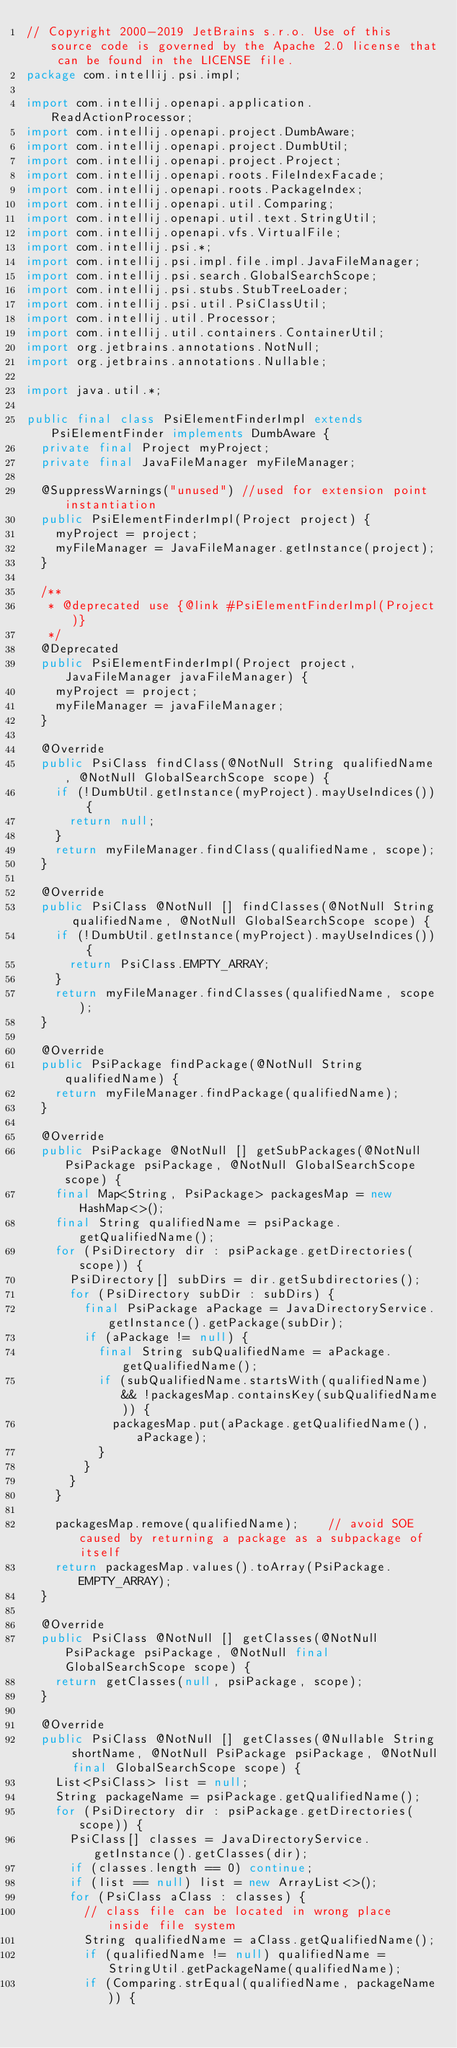<code> <loc_0><loc_0><loc_500><loc_500><_Java_>// Copyright 2000-2019 JetBrains s.r.o. Use of this source code is governed by the Apache 2.0 license that can be found in the LICENSE file.
package com.intellij.psi.impl;

import com.intellij.openapi.application.ReadActionProcessor;
import com.intellij.openapi.project.DumbAware;
import com.intellij.openapi.project.DumbUtil;
import com.intellij.openapi.project.Project;
import com.intellij.openapi.roots.FileIndexFacade;
import com.intellij.openapi.roots.PackageIndex;
import com.intellij.openapi.util.Comparing;
import com.intellij.openapi.util.text.StringUtil;
import com.intellij.openapi.vfs.VirtualFile;
import com.intellij.psi.*;
import com.intellij.psi.impl.file.impl.JavaFileManager;
import com.intellij.psi.search.GlobalSearchScope;
import com.intellij.psi.stubs.StubTreeLoader;
import com.intellij.psi.util.PsiClassUtil;
import com.intellij.util.Processor;
import com.intellij.util.containers.ContainerUtil;
import org.jetbrains.annotations.NotNull;
import org.jetbrains.annotations.Nullable;

import java.util.*;

public final class PsiElementFinderImpl extends PsiElementFinder implements DumbAware {
  private final Project myProject;
  private final JavaFileManager myFileManager;

  @SuppressWarnings("unused") //used for extension point instantiation
  public PsiElementFinderImpl(Project project) {
    myProject = project;
    myFileManager = JavaFileManager.getInstance(project);
  }

  /**
   * @deprecated use {@link #PsiElementFinderImpl(Project)}
   */
  @Deprecated
  public PsiElementFinderImpl(Project project, JavaFileManager javaFileManager) {
    myProject = project;
    myFileManager = javaFileManager;
  }

  @Override
  public PsiClass findClass(@NotNull String qualifiedName, @NotNull GlobalSearchScope scope) {
    if (!DumbUtil.getInstance(myProject).mayUseIndices()) {
      return null;
    }
    return myFileManager.findClass(qualifiedName, scope);
  }

  @Override
  public PsiClass @NotNull [] findClasses(@NotNull String qualifiedName, @NotNull GlobalSearchScope scope) {
    if (!DumbUtil.getInstance(myProject).mayUseIndices()) {
      return PsiClass.EMPTY_ARRAY;
    }
    return myFileManager.findClasses(qualifiedName, scope);
  }

  @Override
  public PsiPackage findPackage(@NotNull String qualifiedName) {
    return myFileManager.findPackage(qualifiedName);
  }

  @Override
  public PsiPackage @NotNull [] getSubPackages(@NotNull PsiPackage psiPackage, @NotNull GlobalSearchScope scope) {
    final Map<String, PsiPackage> packagesMap = new HashMap<>();
    final String qualifiedName = psiPackage.getQualifiedName();
    for (PsiDirectory dir : psiPackage.getDirectories(scope)) {
      PsiDirectory[] subDirs = dir.getSubdirectories();
      for (PsiDirectory subDir : subDirs) {
        final PsiPackage aPackage = JavaDirectoryService.getInstance().getPackage(subDir);
        if (aPackage != null) {
          final String subQualifiedName = aPackage.getQualifiedName();
          if (subQualifiedName.startsWith(qualifiedName) && !packagesMap.containsKey(subQualifiedName)) {
            packagesMap.put(aPackage.getQualifiedName(), aPackage);
          }
        }
      }
    }

    packagesMap.remove(qualifiedName);    // avoid SOE caused by returning a package as a subpackage of itself
    return packagesMap.values().toArray(PsiPackage.EMPTY_ARRAY);
  }

  @Override
  public PsiClass @NotNull [] getClasses(@NotNull PsiPackage psiPackage, @NotNull final GlobalSearchScope scope) {
    return getClasses(null, psiPackage, scope);
  }

  @Override
  public PsiClass @NotNull [] getClasses(@Nullable String shortName, @NotNull PsiPackage psiPackage, @NotNull final GlobalSearchScope scope) {
    List<PsiClass> list = null;
    String packageName = psiPackage.getQualifiedName();
    for (PsiDirectory dir : psiPackage.getDirectories(scope)) {
      PsiClass[] classes = JavaDirectoryService.getInstance().getClasses(dir);
      if (classes.length == 0) continue;
      if (list == null) list = new ArrayList<>();
      for (PsiClass aClass : classes) {
        // class file can be located in wrong place inside file system
        String qualifiedName = aClass.getQualifiedName();
        if (qualifiedName != null) qualifiedName = StringUtil.getPackageName(qualifiedName);
        if (Comparing.strEqual(qualifiedName, packageName)) {</code> 